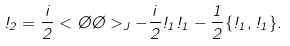Convert formula to latex. <formula><loc_0><loc_0><loc_500><loc_500>\omega _ { 2 } = { \frac { i } { 2 } } < \chi \chi > _ { J } - { \frac { i } { 2 } } \omega _ { 1 } \omega _ { 1 } - { \frac { 1 } { 2 } } \{ \omega _ { 1 } , \omega _ { 1 } \} .</formula> 